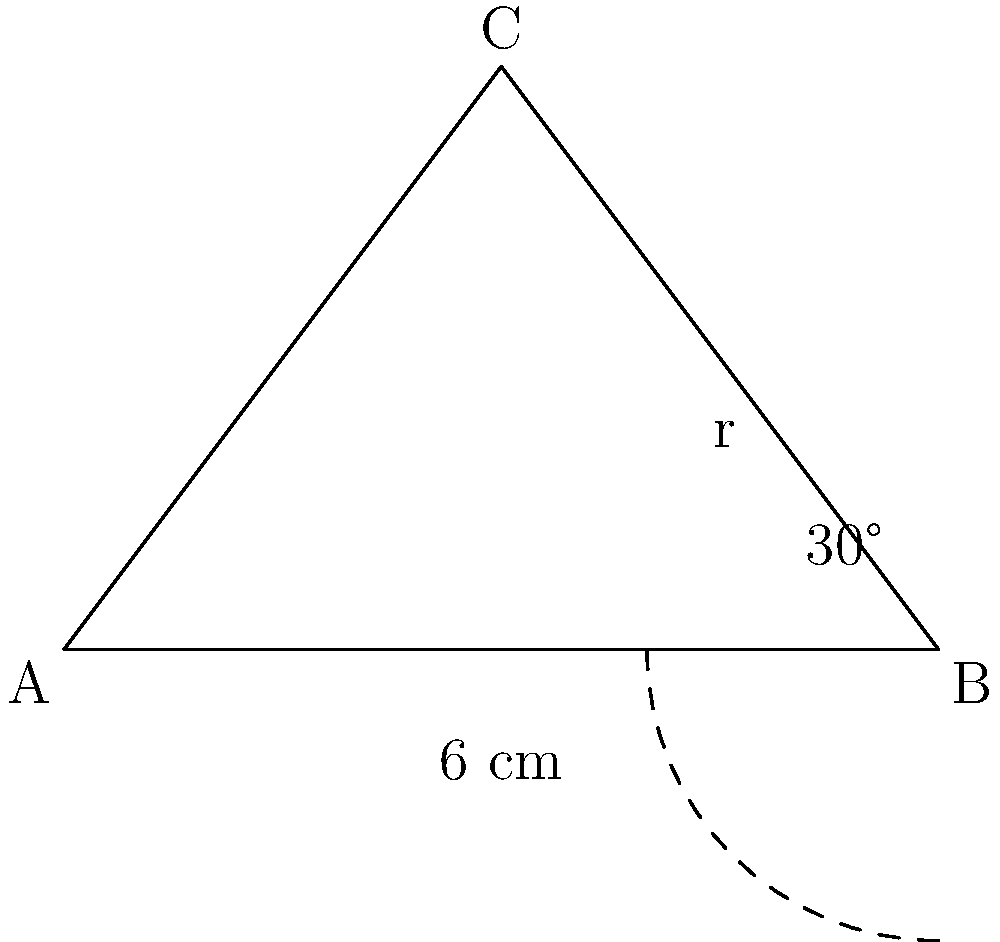A traditional Asian fan is shaped like a sector of a circle. The straight edge of the fan measures 6 cm, and the angle between the two straight edges is 30°. Calculate the area of the fan's surface to the nearest square centimeter. To find the area of the fan, we need to calculate the area of the sector. Let's approach this step-by-step:

1) First, we need to find the radius of the circle. We can do this using the trigonometric ratio for cosine:

   $\cos 15° = \frac{\text{adjacent}}{\text{hypotenuse}} = \frac{3}{r}$

   Note that we use 15° because it's half of the 30° angle.

2) Solving for $r$:

   $r = \frac{3}{\cos 15°} \approx 3.11$ cm

3) Now that we have the radius, we can use the formula for the area of a sector:

   $A = \frac{1}{2} r^2 \theta$

   Where $\theta$ is in radians.

4) We need to convert 30° to radians:

   $30° \times \frac{\pi}{180°} = \frac{\pi}{6}$ radians

5) Now we can plug everything into our formula:

   $A = \frac{1}{2} (3.11)^2 \times \frac{\pi}{6} \approx 2.53$ cm²

6) Rounding to the nearest square centimeter:

   $A \approx 3$ cm²
Answer: 3 cm² 